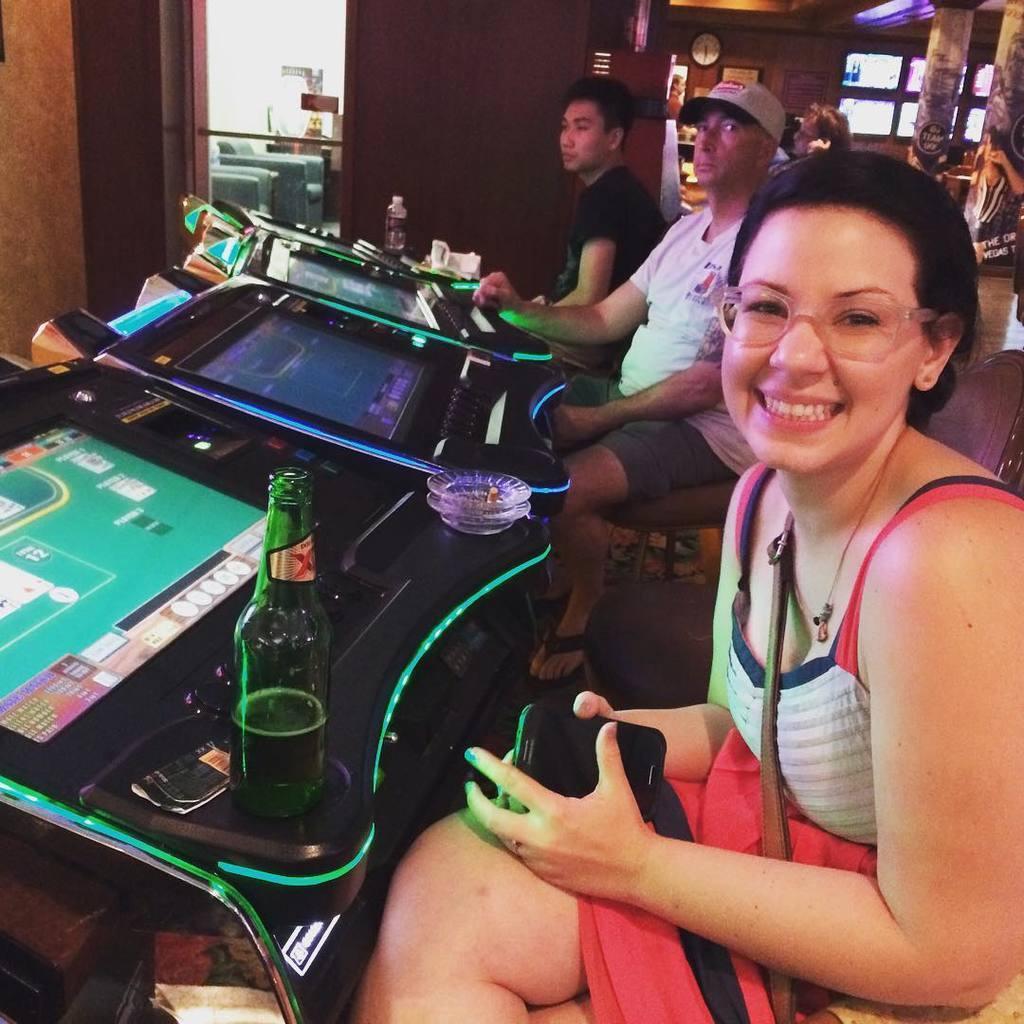In one or two sentences, can you explain what this image depicts? This image is taken indoors. In the background there are a few walls with windows and a door. There is a clock on the wall. On the right side of the image there are two pillars and there are two banners with text on them. A woman is sitting on the chair and she is with a smiling face. She is holding a mobile phone in her hands. In the middle of the image two men are sitting on chairs and there are a few video games on the table. There is a bottle. 